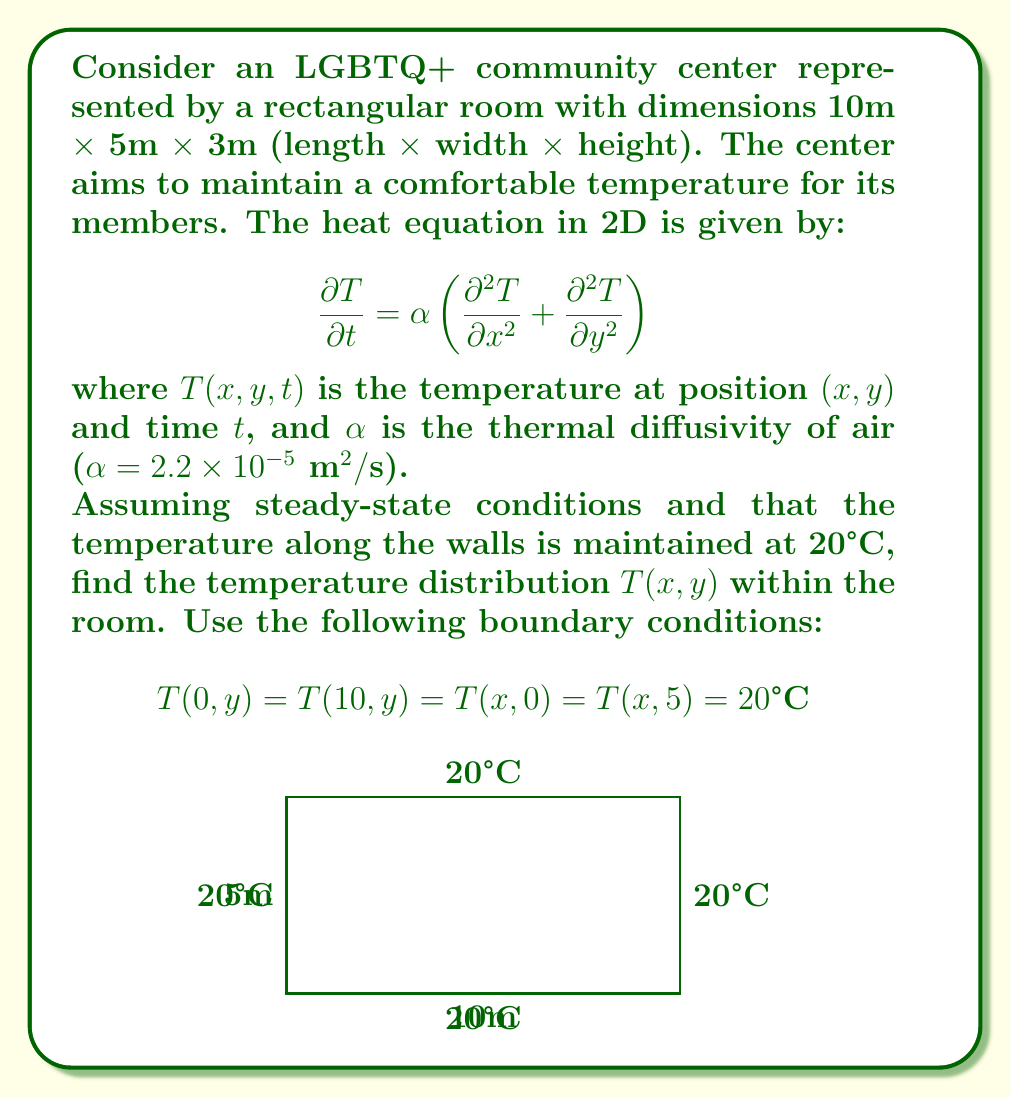Solve this math problem. To solve this problem, we'll follow these steps:

1) In steady-state conditions, $\frac{\partial T}{\partial t} = 0$, so the heat equation reduces to:

   $$\frac{\partial^2 T}{\partial x^2} + \frac{\partial^2 T}{\partial y^2} = 0$$

   This is Laplace's equation in 2D.

2) Given the boundary conditions, we can use the method of separation of variables. Let $T(x,y) = X(x)Y(y)$.

3) Substituting into Laplace's equation:

   $$X''(x)Y(y) + X(x)Y''(y) = 0$$
   $$\frac{X''(x)}{X(x)} = -\frac{Y''(y)}{Y(y)} = -\lambda^2$$

4) This gives us two ODEs:
   
   $$X''(x) + \lambda^2 X(x) = 0$$
   $$Y''(y) - \lambda^2 Y(y) = 0$$

5) The general solutions are:
   
   $$X(x) = A \cos(\lambda x) + B \sin(\lambda x)$$
   $$Y(y) = C e^{\lambda y} + D e^{-\lambda y}$$

6) Applying the boundary conditions:
   
   $T(0,y) = T(10,y) = 20$ implies $X(0) = X(10) = 20$
   $T(x,0) = T(x,5) = 20$ implies $Y(0) = Y(5) = 20$

7) From $X(0) = 20$, we get $A = 20$. From $X(10) = 20$, we get $\lambda = \frac{n\pi}{10}$ where $n$ is an integer.

8) The solution that satisfies all boundary conditions is:

   $$T(x,y) = 20 + \sum_{n=1}^{\infty} B_n \sin(\frac{n\pi x}{10}) \sinh(\frac{n\pi y}{10})$$

   where $B_n$ are constants determined by the specific temperature distribution along the boundaries.

9) Given that all boundaries are at 20°C, $B_n = 0$ for all $n$.

Therefore, the temperature distribution is constant throughout the room.
Answer: $T(x,y) = 20°C$ 